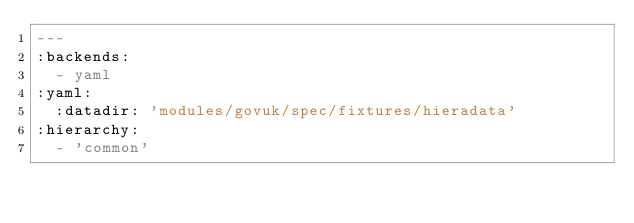Convert code to text. <code><loc_0><loc_0><loc_500><loc_500><_YAML_>---
:backends:
  - yaml
:yaml:
  :datadir: 'modules/govuk/spec/fixtures/hieradata'
:hierarchy:
  - 'common'
</code> 